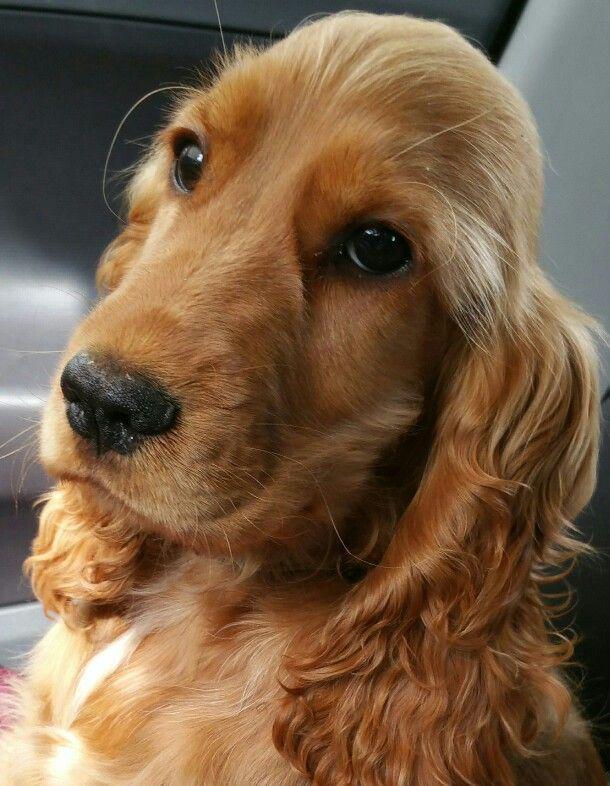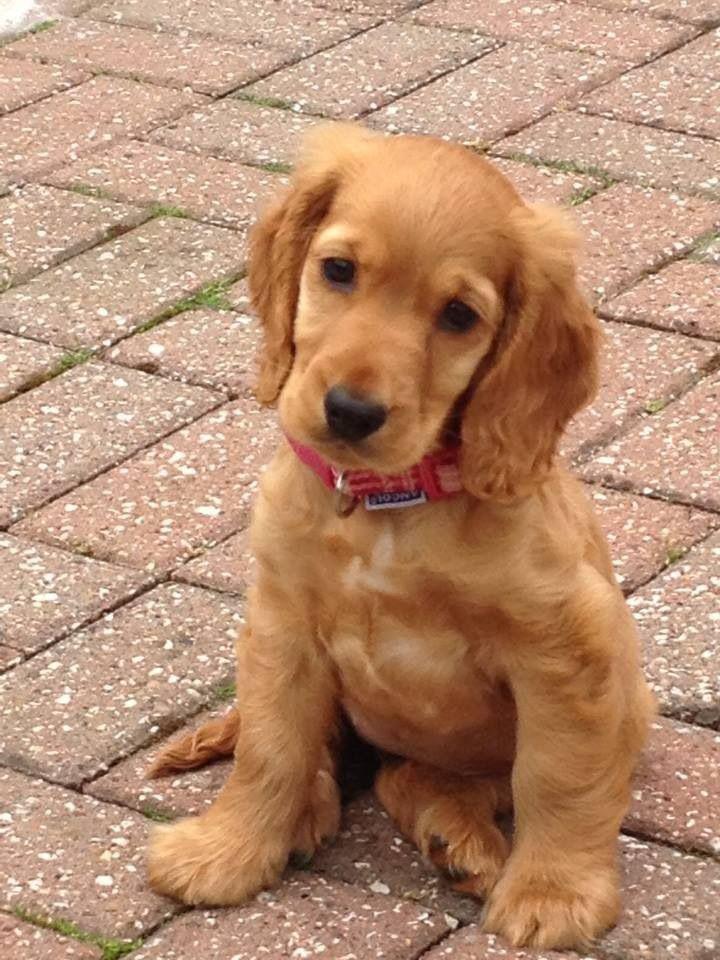The first image is the image on the left, the second image is the image on the right. Considering the images on both sides, is "An image shows a reddish spaniel dog with its paws over a blanket-like piece of fabric." valid? Answer yes or no. No. The first image is the image on the left, the second image is the image on the right. Examine the images to the left and right. Is the description "Exactly two dogs are shown with background settings, each of them the same tan coloring with dark eyes, one wearing a collar and the other not" accurate? Answer yes or no. Yes. 